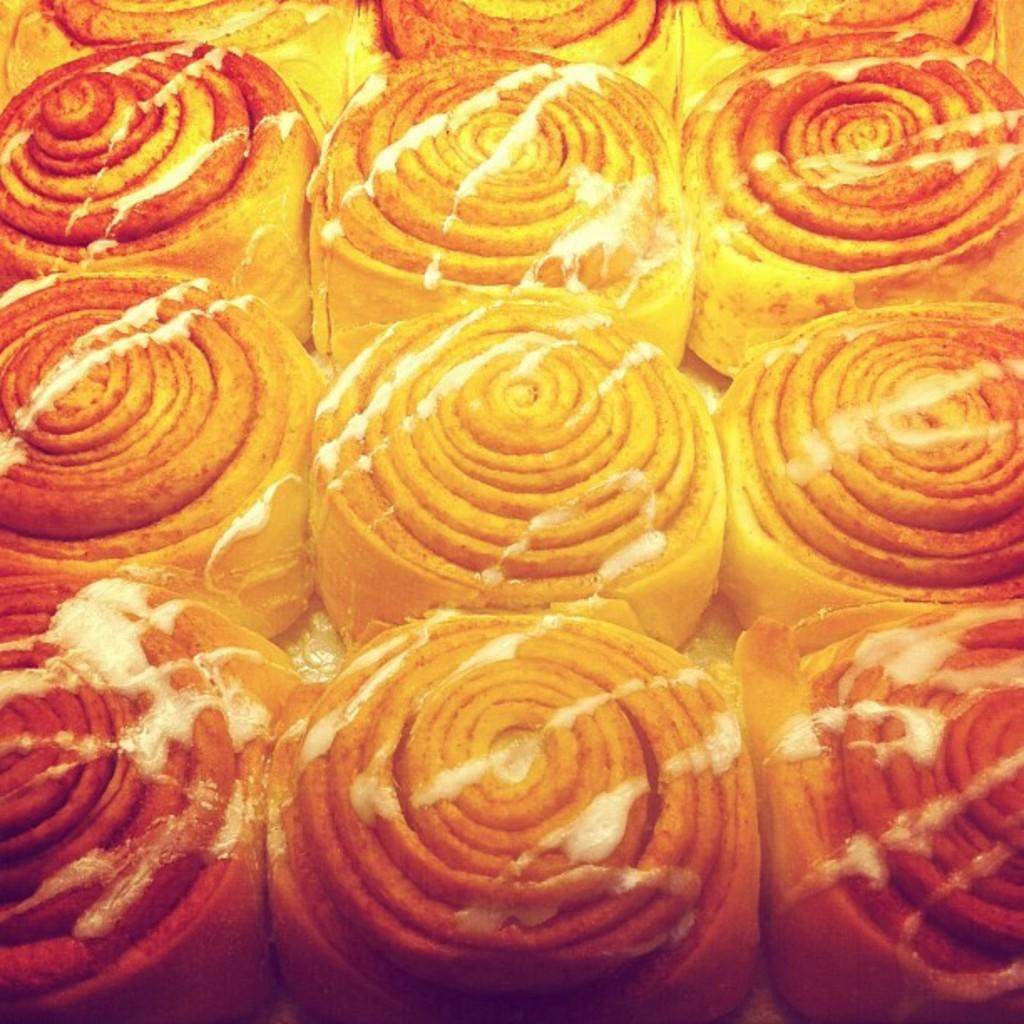What types of items can be seen in the image? There are food items in the image. What sense is being used to solve the riddle in the image? There is no riddle present in the image, so it is not possible to determine which sense is being used to solve it. 